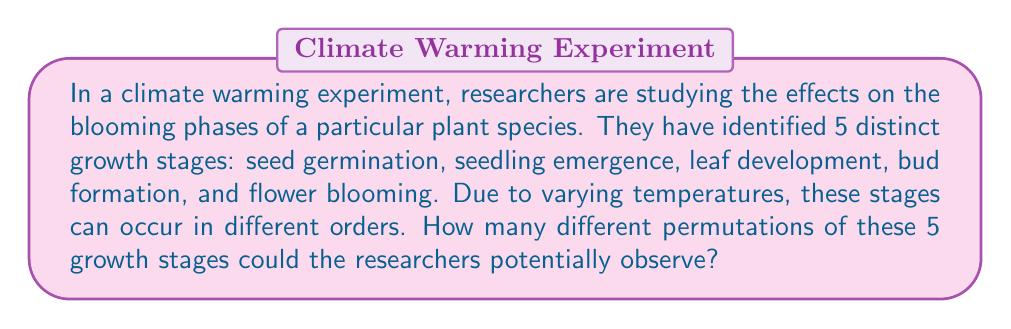Show me your answer to this math problem. To solve this problem, we need to use the concept of permutations from combinatorics. Here's a step-by-step explanation:

1) We have 5 distinct growth stages that can occur in any order. This scenario is a perfect example of a permutation problem.

2) The formula for permutations of n distinct objects is:

   $$P(n) = n!$$

   Where $n!$ represents the factorial of n.

3) In this case, $n = 5$ (5 distinct growth stages).

4) Let's calculate $5!$:

   $$5! = 5 \times 4 \times 3 \times 2 \times 1 = 120$$

5) Therefore, the number of different permutations of these 5 growth stages is 120.

This means that the climate scientists could potentially observe 120 different orders of these growth stages in their warming climate experiment.
Answer: 120 